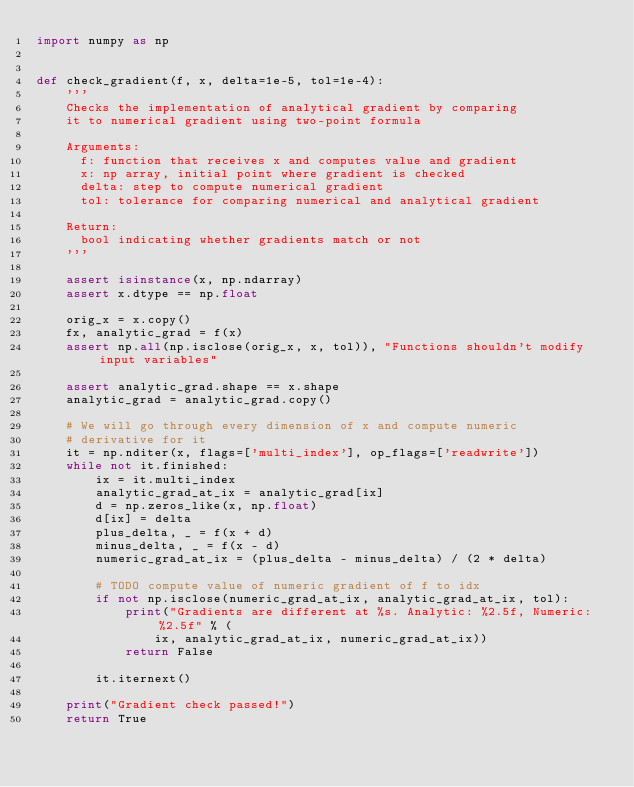<code> <loc_0><loc_0><loc_500><loc_500><_Python_>import numpy as np


def check_gradient(f, x, delta=1e-5, tol=1e-4):
    '''
    Checks the implementation of analytical gradient by comparing
    it to numerical gradient using two-point formula

    Arguments:
      f: function that receives x and computes value and gradient
      x: np array, initial point where gradient is checked
      delta: step to compute numerical gradient
      tol: tolerance for comparing numerical and analytical gradient

    Return:
      bool indicating whether gradients match or not
    '''

    assert isinstance(x, np.ndarray)
    assert x.dtype == np.float

    orig_x = x.copy()
    fx, analytic_grad = f(x)
    assert np.all(np.isclose(orig_x, x, tol)), "Functions shouldn't modify input variables"

    assert analytic_grad.shape == x.shape
    analytic_grad = analytic_grad.copy()

    # We will go through every dimension of x and compute numeric
    # derivative for it
    it = np.nditer(x, flags=['multi_index'], op_flags=['readwrite'])
    while not it.finished:
        ix = it.multi_index
        analytic_grad_at_ix = analytic_grad[ix]
        d = np.zeros_like(x, np.float)
        d[ix] = delta
        plus_delta, _ = f(x + d)
        minus_delta, _ = f(x - d)
        numeric_grad_at_ix = (plus_delta - minus_delta) / (2 * delta)

        # TODO compute value of numeric gradient of f to idx
        if not np.isclose(numeric_grad_at_ix, analytic_grad_at_ix, tol):
            print("Gradients are different at %s. Analytic: %2.5f, Numeric: %2.5f" % (
                ix, analytic_grad_at_ix, numeric_grad_at_ix))
            return False

        it.iternext()

    print("Gradient check passed!")
    return True
</code> 